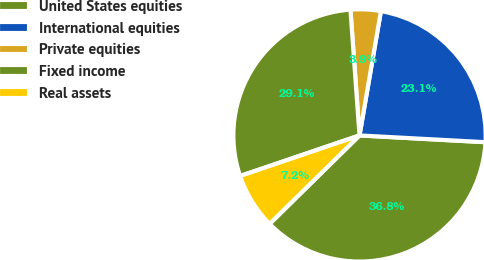Convert chart. <chart><loc_0><loc_0><loc_500><loc_500><pie_chart><fcel>United States equities<fcel>International equities<fcel>Private equities<fcel>Fixed income<fcel>Real assets<nl><fcel>36.78%<fcel>23.14%<fcel>3.86%<fcel>29.07%<fcel>7.15%<nl></chart> 